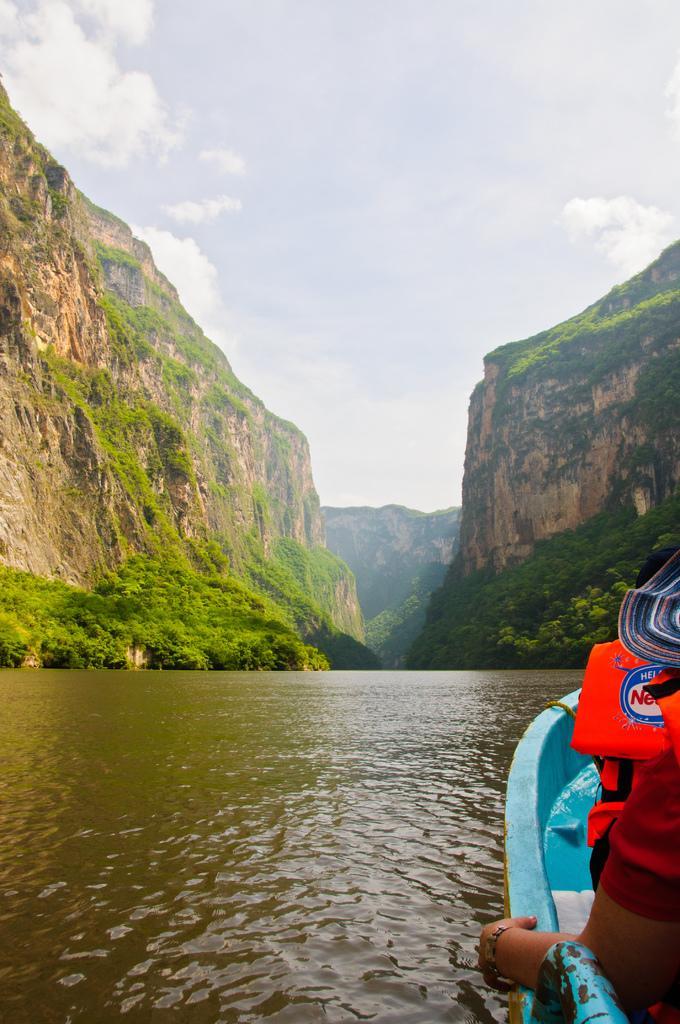Please provide a concise description of this image. In this image there is one person sitting on the boat as we can see on the bottom right corner of this image and there is a river on the bottom of this image and there are some trees in the background and there are some mountains on the top of this image ,and there is a sky at top of this image. 